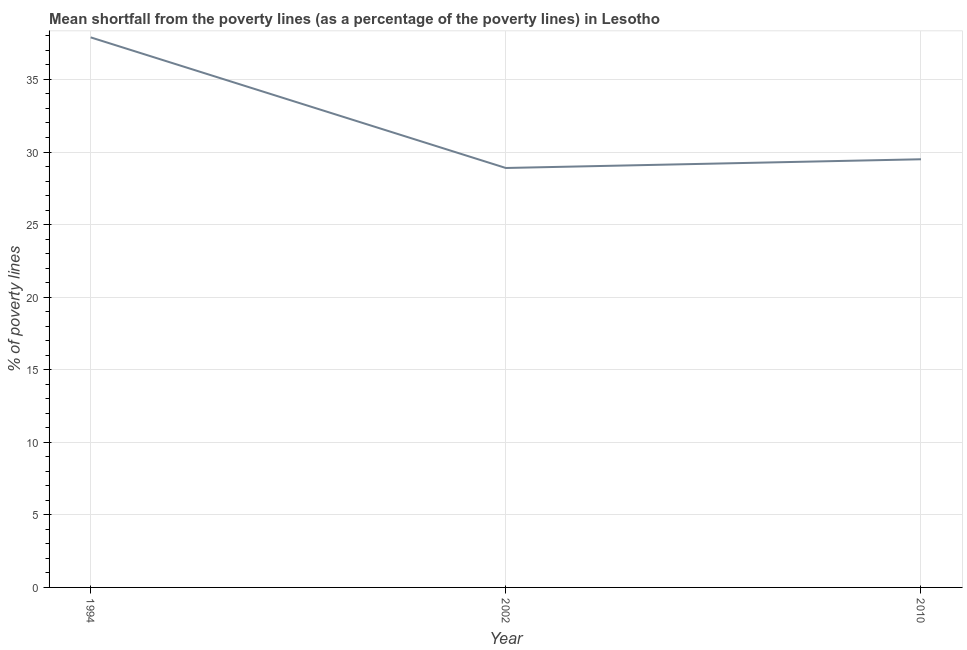What is the poverty gap at national poverty lines in 1994?
Keep it short and to the point. 37.9. Across all years, what is the maximum poverty gap at national poverty lines?
Your answer should be compact. 37.9. Across all years, what is the minimum poverty gap at national poverty lines?
Provide a short and direct response. 28.9. What is the sum of the poverty gap at national poverty lines?
Offer a terse response. 96.3. What is the difference between the poverty gap at national poverty lines in 2002 and 2010?
Your answer should be compact. -0.6. What is the average poverty gap at national poverty lines per year?
Give a very brief answer. 32.1. What is the median poverty gap at national poverty lines?
Your answer should be compact. 29.5. In how many years, is the poverty gap at national poverty lines greater than 16 %?
Make the answer very short. 3. Do a majority of the years between 1994 and 2002 (inclusive) have poverty gap at national poverty lines greater than 35 %?
Ensure brevity in your answer.  No. What is the ratio of the poverty gap at national poverty lines in 1994 to that in 2010?
Offer a very short reply. 1.28. Is the poverty gap at national poverty lines in 1994 less than that in 2002?
Keep it short and to the point. No. Is the difference between the poverty gap at national poverty lines in 1994 and 2002 greater than the difference between any two years?
Keep it short and to the point. Yes. What is the difference between the highest and the second highest poverty gap at national poverty lines?
Make the answer very short. 8.4. Is the sum of the poverty gap at national poverty lines in 1994 and 2010 greater than the maximum poverty gap at national poverty lines across all years?
Make the answer very short. Yes. How many years are there in the graph?
Your response must be concise. 3. What is the difference between two consecutive major ticks on the Y-axis?
Your answer should be very brief. 5. What is the title of the graph?
Make the answer very short. Mean shortfall from the poverty lines (as a percentage of the poverty lines) in Lesotho. What is the label or title of the X-axis?
Give a very brief answer. Year. What is the label or title of the Y-axis?
Offer a very short reply. % of poverty lines. What is the % of poverty lines in 1994?
Your answer should be very brief. 37.9. What is the % of poverty lines of 2002?
Offer a very short reply. 28.9. What is the % of poverty lines in 2010?
Make the answer very short. 29.5. What is the difference between the % of poverty lines in 1994 and 2010?
Provide a succinct answer. 8.4. What is the difference between the % of poverty lines in 2002 and 2010?
Ensure brevity in your answer.  -0.6. What is the ratio of the % of poverty lines in 1994 to that in 2002?
Keep it short and to the point. 1.31. What is the ratio of the % of poverty lines in 1994 to that in 2010?
Offer a terse response. 1.28. 